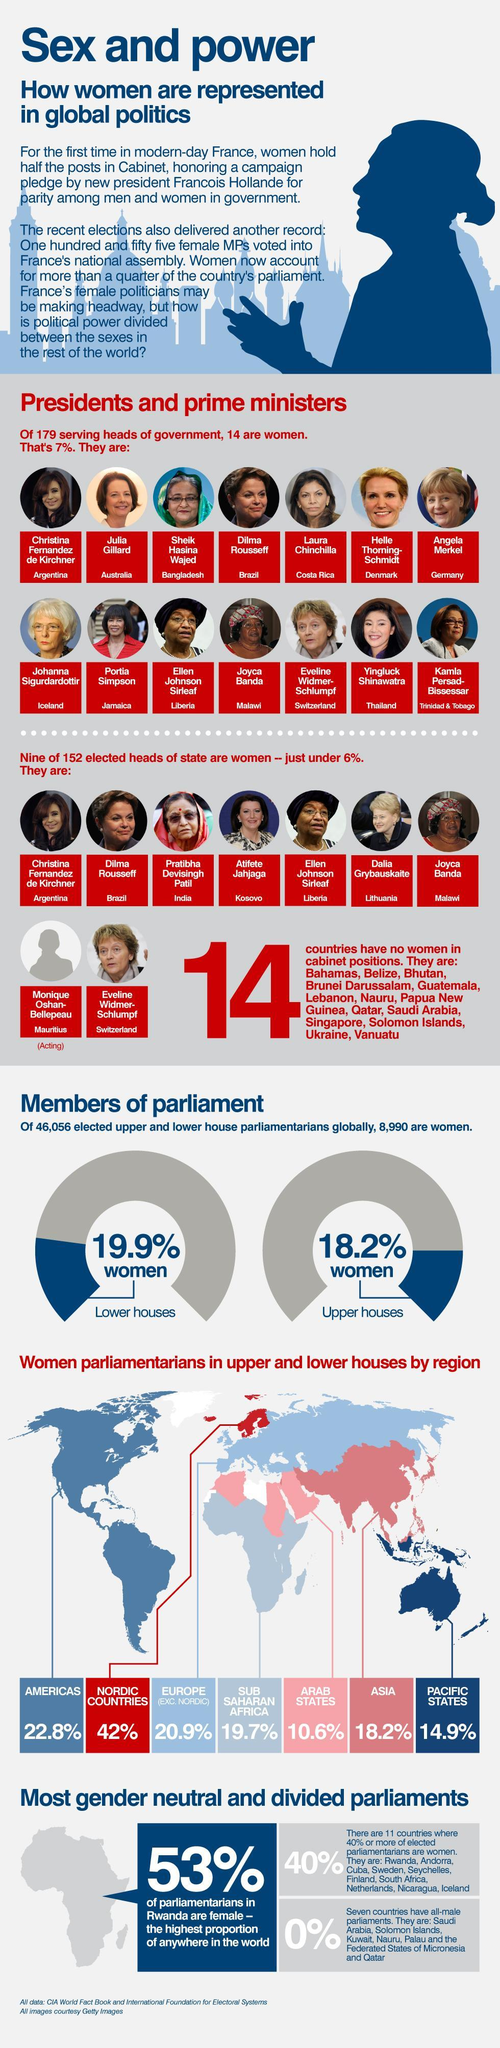Of the total number of parliamentarians in the world, how many are women?
Answer the question with a short phrase. 8990 What is the percentage of women parliamentarians in the Americas? 22.8% Who is the woman leader from India? Pratibha DeviSingh Patil How many parliaments have only men as their members? 7 Which three countries have the most number of women parliamentarians? Rwanda, Andorra, Cuba Which region has a higher percentage of women parliamentarians - Pacific States, Sub Saharan Africa or the Arab States? Sub Saharan Africa What percentage of the parliamentarians in Rwanda are females? 53% What is the percentage of women parliamentarians in the Nordic countries? 42% What percentage of the parliamentarians In The upper house are women? 18.2% Which region has a higher percentage of women parliamentarians, Asia or the Arab States? Asia What is the percentage of women parliamentarians in the Pacific States? 14.9% Which region has the highest number of women parliamentarians? Nordic countries What percentage of the parliamentarians in the lower house are women? 19.9% Which country does Julia Gillard represent? Australia How many parliaments have above 40% of  women parliamentarians? 11 Of the total number of parliamentarians (global), how many are men? 37066 Who was the woman leader in Bangladesh? Sheik Hasina Wajed 